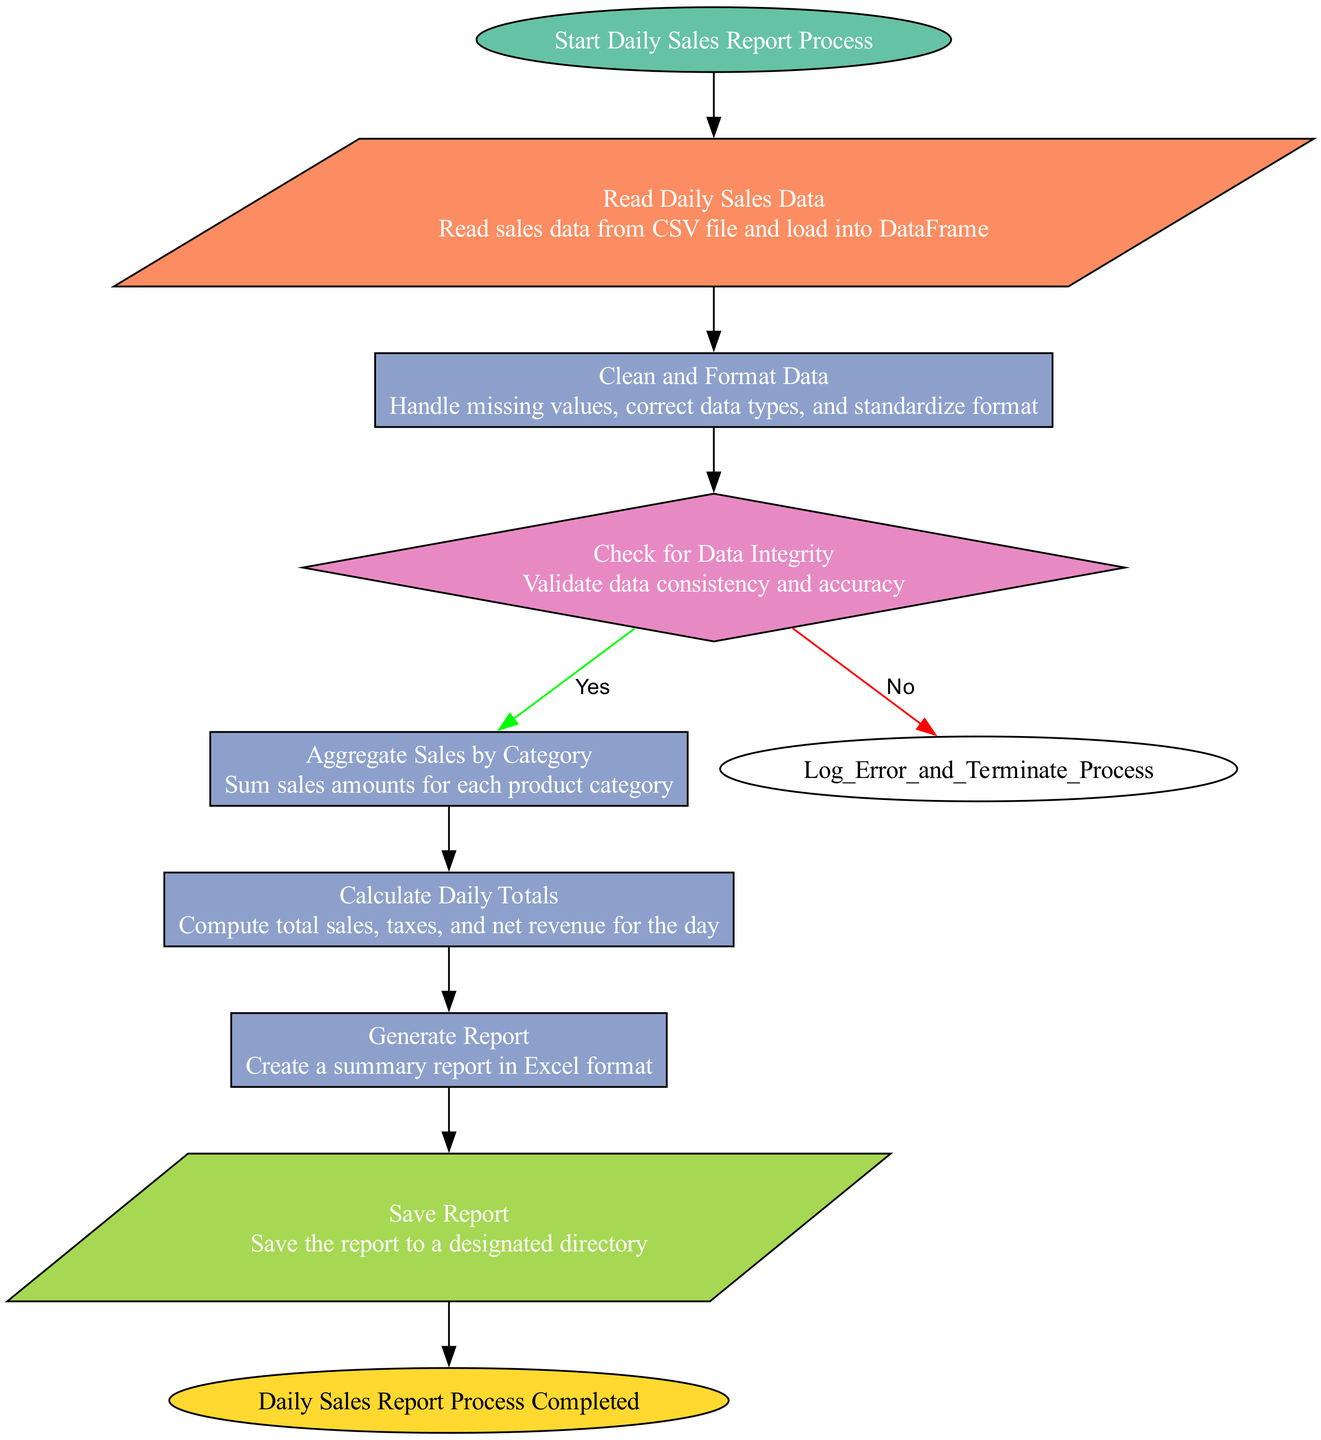What is the first step in the process? The first step in the process is labeled as "Start Daily Sales Report Process". This node indicates the initiation of the entire flowchart.
Answer: Start Daily Sales Report Process How many decision points are in the flowchart? There is one decision point represented by the "Check for Data Integrity" node, which includes two possible outcomes: Yes or No.
Answer: 1 What happens if data integrity check fails? If the data integrity check fails, the flowchart proceeds to the "Log Error and Terminate Process" step, indicating that the process will stop.
Answer: Log Error and Terminate Process What is created after calculating daily totals? After calculating daily totals, the next step is to "Generate Report", where a summary report is created in Excel format.
Answer: Generate Report What shapes are used for process nodes? The process nodes in the flowchart are represented using rectangles, as indicated by their shape description in the node styles.
Answer: Rectangle What are the outputs in the diagram? There is one output described as "Save Report", which indicates that the report will be saved to a designated directory after it is generated.
Answer: Save Report What step follows the "Aggregate Sales by Category"? The step that follows "Aggregate Sales by Category" is "Calculate Daily Totals", indicating the flow of operations in the process.
Answer: Calculate Daily Totals What color represents the 'Start' node? The 'Start' node is represented with a fill color of green, specifically "#66c2a5", according to the diagram's color coding.
Answer: Green What is the final step in this process? The final step in the process is labeled "Daily Sales Report Process Completed", indicating the conclusion of the sales reporting process.
Answer: Daily Sales Report Process Completed 